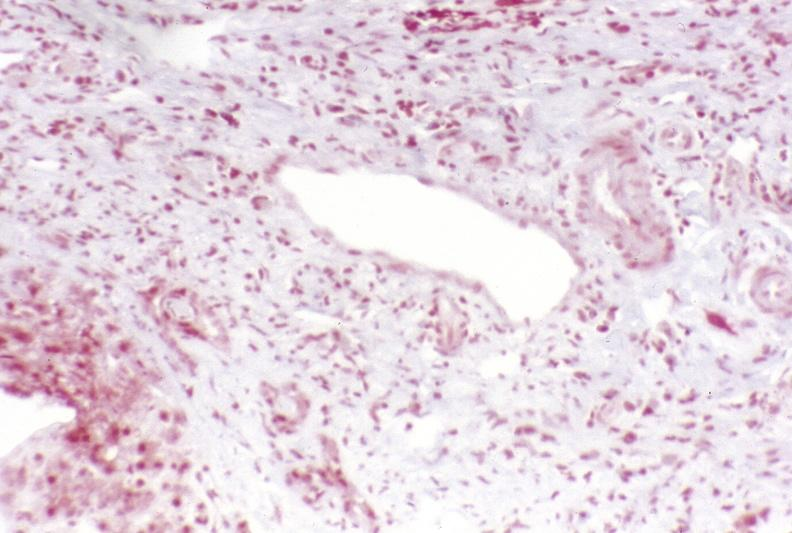does mucinous cystadenocarcinoma show primary sclerosing cholangitis?
Answer the question using a single word or phrase. No 